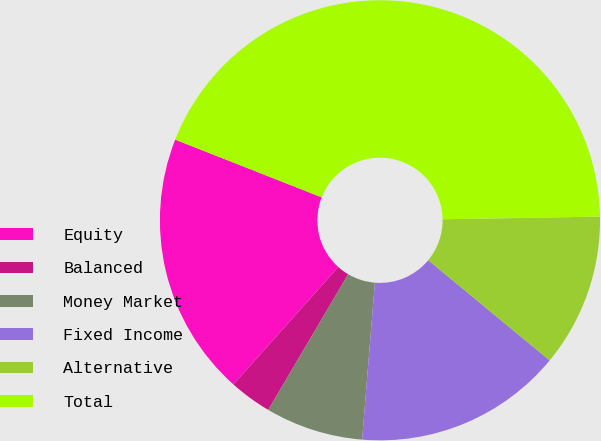Convert chart to OTSL. <chart><loc_0><loc_0><loc_500><loc_500><pie_chart><fcel>Equity<fcel>Balanced<fcel>Money Market<fcel>Fixed Income<fcel>Alternative<fcel>Total<nl><fcel>19.38%<fcel>3.12%<fcel>7.18%<fcel>15.31%<fcel>11.25%<fcel>43.76%<nl></chart> 